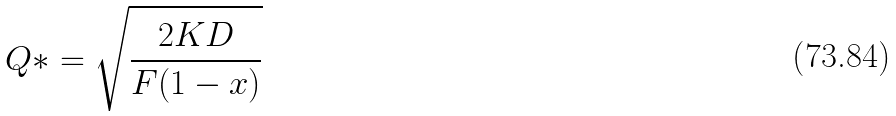<formula> <loc_0><loc_0><loc_500><loc_500>Q * = \sqrt { \frac { 2 K D } { F ( 1 - x ) } }</formula> 